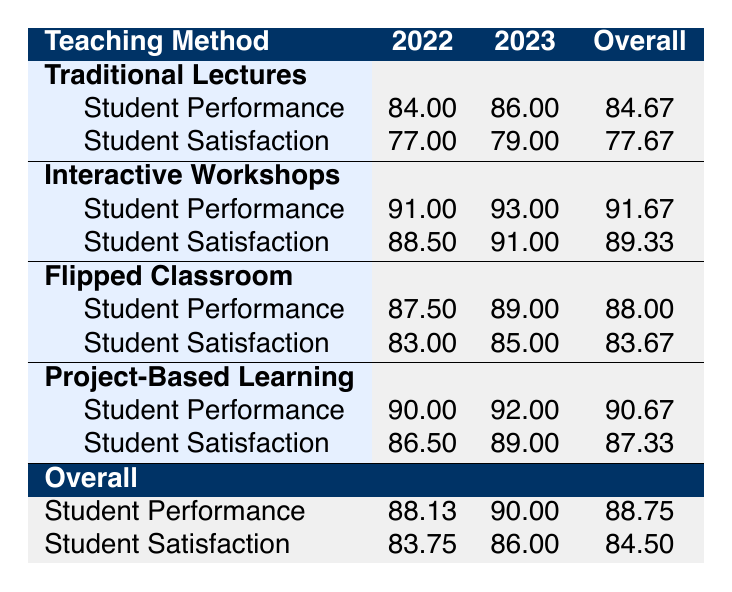What is the student performance for Traditional Lectures in 2022? From the table, we can see that for Traditional Lectures, the student performance in 2022 is listed as 84.00.
Answer: 84.00 What is the average student satisfaction for Project-Based Learning across both years? For Project-Based Learning, student satisfaction in 2022 is 86.50 and in 2023 is 89.00. The average is calculated as (86.50 + 89.00) / 2 = 87.75.
Answer: 87.75 Is the student performance for Interactive Workshops higher than that for Flipped Classroom in 2023? In 2023, the student performance for Interactive Workshops is 93.00, while for Flipped Classroom, it is 89.00. Since 93.00 is greater than 89.00, the statement is true.
Answer: Yes What is the difference in average student satisfaction between Traditional Lectures and Flipped Classroom for 2022? For Traditional Lectures, the student satisfaction in 2022 is 77.00; for Flipped Classroom, it is 83.00. The difference is calculated as 83.00 - 77.00 = 6.00.
Answer: 6.00 What teaching method had the highest average student performance across both years? To find the highest average, we calculate the averages for each method: Traditional Lectures (84.67), Interactive Workshops (91.67), Flipped Classroom (88.00), Project-Based Learning (90.67). Interactive Workshops has the highest average at 91.67.
Answer: Interactive Workshops In which year did Project-Based Learning have a lower student satisfaction than Interactive Workshops? For Project-Based Learning, the student satisfaction was 86.50 in 2022 and 89.00 in 2023. For Interactive Workshops, the satisfaction was 88.50 in 2022 and 91.00 in 2023. In 2022, Project-Based Learning (86.50) was lower than Interactive Workshops (88.50). Hence, 2022 is the answer.
Answer: 2022 